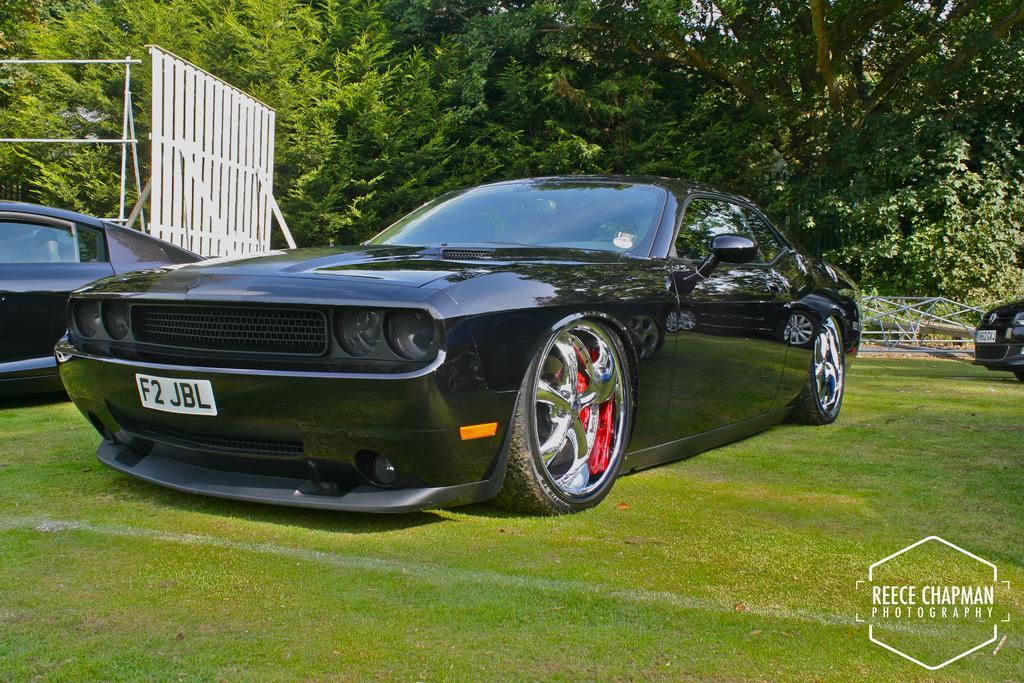In one or two sentences, can you explain what this image depicts? In this image, we can see a car is parked on the grass. In the background, we can see vehicles, rods, plants and trees. In the bottom right corner of the image, we can see the watermarks. 